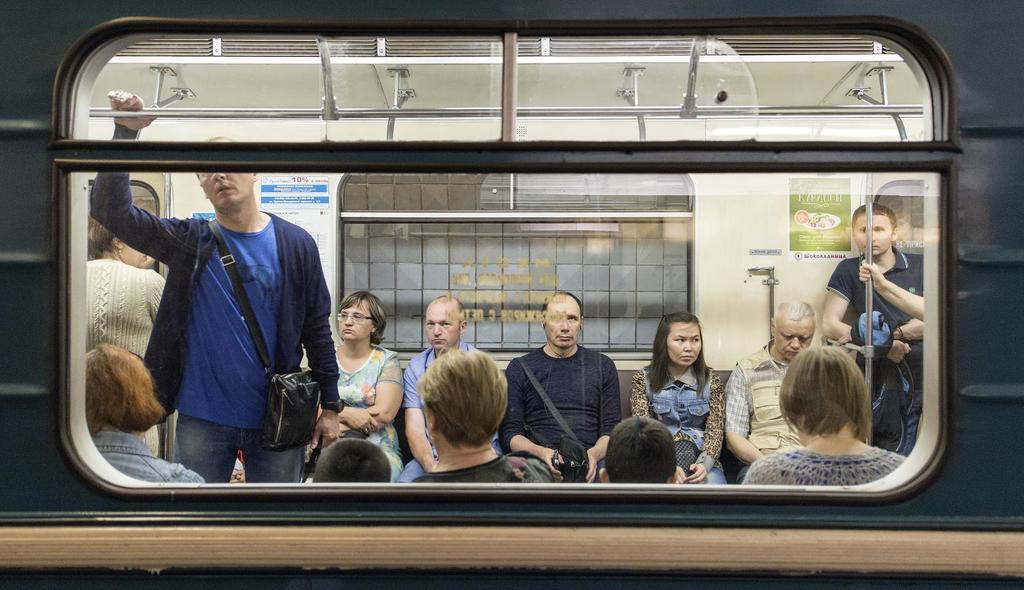What are the people in the image doing? There are people sitting and standing in the image. What can be seen through the windows in the image? The presence of windows suggests that there is a view outside, but the specifics are not mentioned in the facts. What are the rods used for in the image? The purpose of the rods is not specified in the facts. What are the bags used for in the image? The bags might be used for carrying items or belongings, but their specific purpose is not mentioned in the facts. What types of objects can be seen in the image? There are objects in the image, but their specific nature is not mentioned in the facts. What is depicted on the posters on the walls in the image? The content of the posters is not mentioned in the facts. Can you tell me how many quivers are hanging on the wall in the image? There is no mention of quivers in the image, so it is not possible to answer this question. 